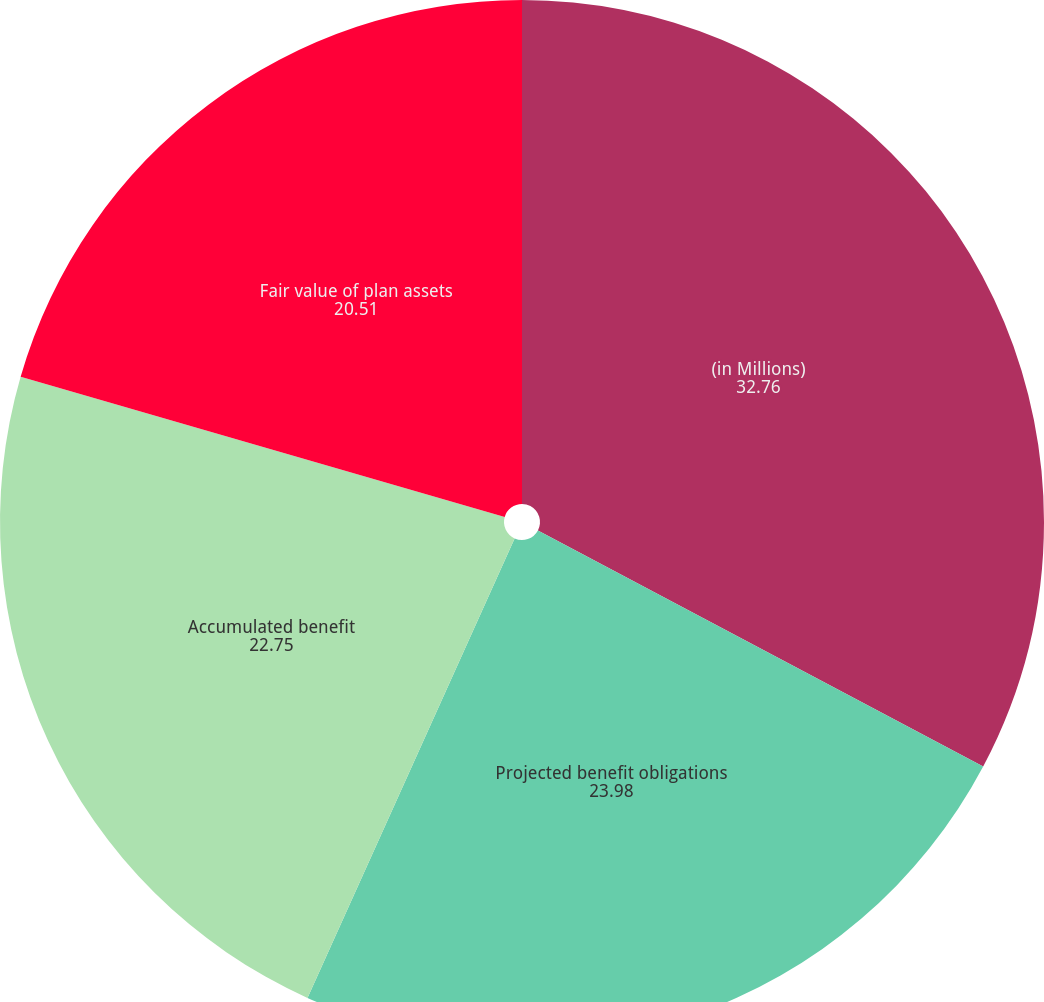Convert chart to OTSL. <chart><loc_0><loc_0><loc_500><loc_500><pie_chart><fcel>(in Millions)<fcel>Projected benefit obligations<fcel>Accumulated benefit<fcel>Fair value of plan assets<nl><fcel>32.76%<fcel>23.98%<fcel>22.75%<fcel>20.51%<nl></chart> 